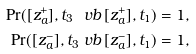<formula> <loc_0><loc_0><loc_500><loc_500>\Pr ( [ z ^ { + } _ { a } ] , t _ { 3 } \ v b \, [ z ^ { + } _ { a } ] , t _ { 1 } ) & = 1 , \\ \Pr ( [ z ^ { - } _ { a } ] , t _ { 3 } \ v b \, [ z ^ { - } _ { a } ] , t _ { 1 } ) & = 1 ,</formula> 